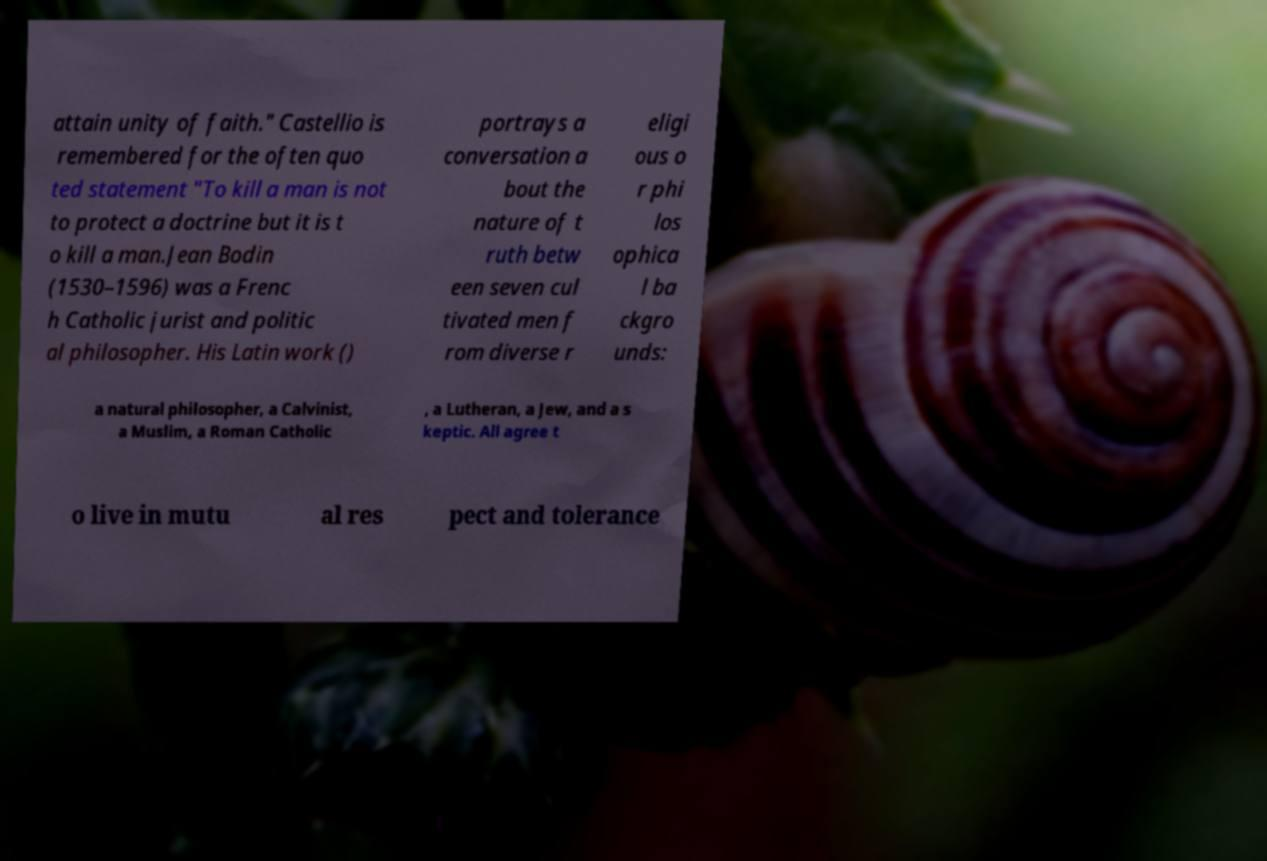Could you assist in decoding the text presented in this image and type it out clearly? attain unity of faith." Castellio is remembered for the often quo ted statement "To kill a man is not to protect a doctrine but it is t o kill a man.Jean Bodin (1530–1596) was a Frenc h Catholic jurist and politic al philosopher. His Latin work () portrays a conversation a bout the nature of t ruth betw een seven cul tivated men f rom diverse r eligi ous o r phi los ophica l ba ckgro unds: a natural philosopher, a Calvinist, a Muslim, a Roman Catholic , a Lutheran, a Jew, and a s keptic. All agree t o live in mutu al res pect and tolerance 